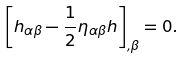Convert formula to latex. <formula><loc_0><loc_0><loc_500><loc_500>\left [ h _ { \alpha \beta } - \frac { 1 } { 2 } \eta _ { \alpha \beta } h \right ] _ { , \beta } = 0 .</formula> 